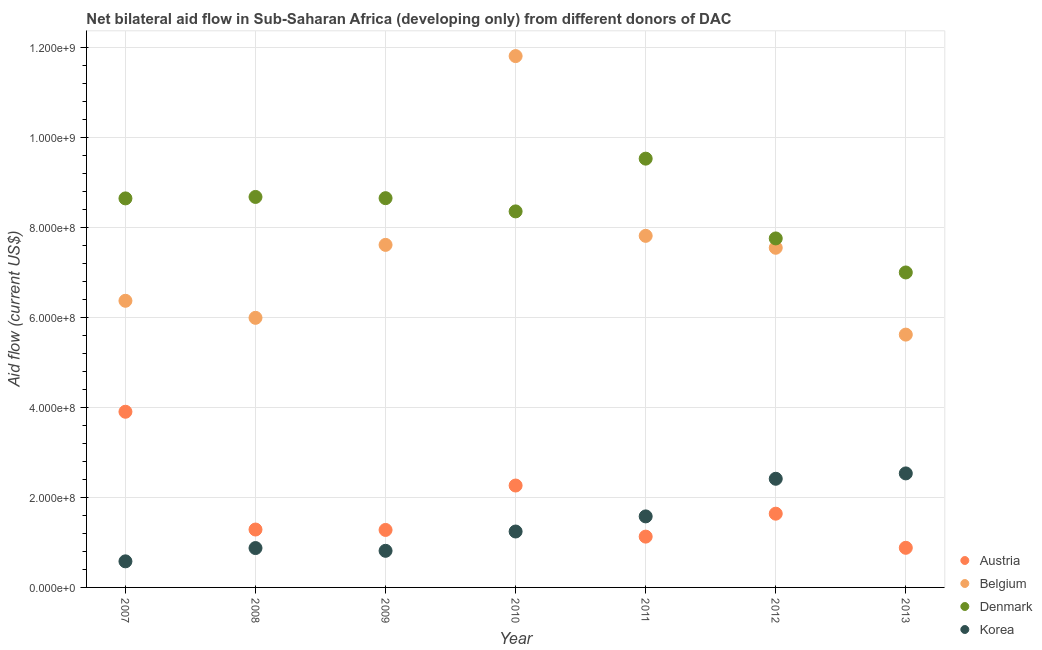Is the number of dotlines equal to the number of legend labels?
Your answer should be very brief. Yes. What is the amount of aid given by korea in 2010?
Provide a succinct answer. 1.24e+08. Across all years, what is the maximum amount of aid given by austria?
Give a very brief answer. 3.91e+08. Across all years, what is the minimum amount of aid given by belgium?
Your response must be concise. 5.62e+08. In which year was the amount of aid given by austria maximum?
Offer a terse response. 2007. What is the total amount of aid given by belgium in the graph?
Offer a terse response. 5.28e+09. What is the difference between the amount of aid given by austria in 2007 and that in 2010?
Your answer should be very brief. 1.64e+08. What is the difference between the amount of aid given by korea in 2011 and the amount of aid given by austria in 2010?
Your answer should be very brief. -6.86e+07. What is the average amount of aid given by korea per year?
Your response must be concise. 1.44e+08. In the year 2010, what is the difference between the amount of aid given by korea and amount of aid given by denmark?
Your answer should be very brief. -7.12e+08. What is the ratio of the amount of aid given by austria in 2011 to that in 2013?
Your response must be concise. 1.28. Is the amount of aid given by korea in 2007 less than that in 2009?
Your answer should be very brief. Yes. Is the difference between the amount of aid given by belgium in 2009 and 2011 greater than the difference between the amount of aid given by denmark in 2009 and 2011?
Ensure brevity in your answer.  Yes. What is the difference between the highest and the second highest amount of aid given by korea?
Offer a very short reply. 1.19e+07. What is the difference between the highest and the lowest amount of aid given by belgium?
Keep it short and to the point. 6.19e+08. Is the sum of the amount of aid given by belgium in 2008 and 2009 greater than the maximum amount of aid given by denmark across all years?
Give a very brief answer. Yes. Is the amount of aid given by denmark strictly greater than the amount of aid given by korea over the years?
Offer a terse response. Yes. How many dotlines are there?
Ensure brevity in your answer.  4. Where does the legend appear in the graph?
Ensure brevity in your answer.  Bottom right. How many legend labels are there?
Give a very brief answer. 4. What is the title of the graph?
Offer a very short reply. Net bilateral aid flow in Sub-Saharan Africa (developing only) from different donors of DAC. What is the Aid flow (current US$) in Austria in 2007?
Give a very brief answer. 3.91e+08. What is the Aid flow (current US$) in Belgium in 2007?
Your response must be concise. 6.38e+08. What is the Aid flow (current US$) of Denmark in 2007?
Give a very brief answer. 8.65e+08. What is the Aid flow (current US$) in Korea in 2007?
Keep it short and to the point. 5.80e+07. What is the Aid flow (current US$) of Austria in 2008?
Your answer should be very brief. 1.29e+08. What is the Aid flow (current US$) of Belgium in 2008?
Your answer should be very brief. 6.00e+08. What is the Aid flow (current US$) of Denmark in 2008?
Provide a succinct answer. 8.68e+08. What is the Aid flow (current US$) of Korea in 2008?
Your response must be concise. 8.76e+07. What is the Aid flow (current US$) of Austria in 2009?
Provide a succinct answer. 1.28e+08. What is the Aid flow (current US$) of Belgium in 2009?
Your answer should be compact. 7.62e+08. What is the Aid flow (current US$) of Denmark in 2009?
Provide a succinct answer. 8.66e+08. What is the Aid flow (current US$) of Korea in 2009?
Make the answer very short. 8.14e+07. What is the Aid flow (current US$) in Austria in 2010?
Provide a succinct answer. 2.27e+08. What is the Aid flow (current US$) in Belgium in 2010?
Your response must be concise. 1.18e+09. What is the Aid flow (current US$) in Denmark in 2010?
Your answer should be very brief. 8.36e+08. What is the Aid flow (current US$) of Korea in 2010?
Provide a succinct answer. 1.24e+08. What is the Aid flow (current US$) in Austria in 2011?
Provide a short and direct response. 1.13e+08. What is the Aid flow (current US$) of Belgium in 2011?
Offer a terse response. 7.82e+08. What is the Aid flow (current US$) in Denmark in 2011?
Your answer should be very brief. 9.54e+08. What is the Aid flow (current US$) of Korea in 2011?
Keep it short and to the point. 1.58e+08. What is the Aid flow (current US$) of Austria in 2012?
Your answer should be compact. 1.64e+08. What is the Aid flow (current US$) of Belgium in 2012?
Provide a succinct answer. 7.55e+08. What is the Aid flow (current US$) of Denmark in 2012?
Make the answer very short. 7.76e+08. What is the Aid flow (current US$) in Korea in 2012?
Provide a succinct answer. 2.42e+08. What is the Aid flow (current US$) in Austria in 2013?
Your response must be concise. 8.81e+07. What is the Aid flow (current US$) of Belgium in 2013?
Your response must be concise. 5.62e+08. What is the Aid flow (current US$) in Denmark in 2013?
Provide a short and direct response. 7.01e+08. What is the Aid flow (current US$) of Korea in 2013?
Give a very brief answer. 2.54e+08. Across all years, what is the maximum Aid flow (current US$) in Austria?
Your response must be concise. 3.91e+08. Across all years, what is the maximum Aid flow (current US$) of Belgium?
Provide a short and direct response. 1.18e+09. Across all years, what is the maximum Aid flow (current US$) of Denmark?
Provide a succinct answer. 9.54e+08. Across all years, what is the maximum Aid flow (current US$) of Korea?
Your answer should be compact. 2.54e+08. Across all years, what is the minimum Aid flow (current US$) in Austria?
Your answer should be compact. 8.81e+07. Across all years, what is the minimum Aid flow (current US$) of Belgium?
Provide a short and direct response. 5.62e+08. Across all years, what is the minimum Aid flow (current US$) of Denmark?
Keep it short and to the point. 7.01e+08. Across all years, what is the minimum Aid flow (current US$) in Korea?
Ensure brevity in your answer.  5.80e+07. What is the total Aid flow (current US$) in Austria in the graph?
Keep it short and to the point. 1.24e+09. What is the total Aid flow (current US$) of Belgium in the graph?
Your answer should be compact. 5.28e+09. What is the total Aid flow (current US$) of Denmark in the graph?
Ensure brevity in your answer.  5.87e+09. What is the total Aid flow (current US$) of Korea in the graph?
Provide a succinct answer. 1.00e+09. What is the difference between the Aid flow (current US$) of Austria in 2007 and that in 2008?
Ensure brevity in your answer.  2.62e+08. What is the difference between the Aid flow (current US$) of Belgium in 2007 and that in 2008?
Keep it short and to the point. 3.79e+07. What is the difference between the Aid flow (current US$) in Denmark in 2007 and that in 2008?
Offer a very short reply. -3.24e+06. What is the difference between the Aid flow (current US$) in Korea in 2007 and that in 2008?
Make the answer very short. -2.95e+07. What is the difference between the Aid flow (current US$) in Austria in 2007 and that in 2009?
Ensure brevity in your answer.  2.63e+08. What is the difference between the Aid flow (current US$) of Belgium in 2007 and that in 2009?
Provide a short and direct response. -1.24e+08. What is the difference between the Aid flow (current US$) in Denmark in 2007 and that in 2009?
Your answer should be very brief. -5.00e+05. What is the difference between the Aid flow (current US$) of Korea in 2007 and that in 2009?
Provide a short and direct response. -2.34e+07. What is the difference between the Aid flow (current US$) in Austria in 2007 and that in 2010?
Provide a succinct answer. 1.64e+08. What is the difference between the Aid flow (current US$) of Belgium in 2007 and that in 2010?
Provide a succinct answer. -5.44e+08. What is the difference between the Aid flow (current US$) in Denmark in 2007 and that in 2010?
Keep it short and to the point. 2.89e+07. What is the difference between the Aid flow (current US$) of Korea in 2007 and that in 2010?
Keep it short and to the point. -6.64e+07. What is the difference between the Aid flow (current US$) of Austria in 2007 and that in 2011?
Provide a succinct answer. 2.78e+08. What is the difference between the Aid flow (current US$) in Belgium in 2007 and that in 2011?
Provide a succinct answer. -1.44e+08. What is the difference between the Aid flow (current US$) of Denmark in 2007 and that in 2011?
Your answer should be compact. -8.84e+07. What is the difference between the Aid flow (current US$) of Korea in 2007 and that in 2011?
Provide a short and direct response. -1.00e+08. What is the difference between the Aid flow (current US$) in Austria in 2007 and that in 2012?
Your answer should be very brief. 2.27e+08. What is the difference between the Aid flow (current US$) in Belgium in 2007 and that in 2012?
Make the answer very short. -1.18e+08. What is the difference between the Aid flow (current US$) of Denmark in 2007 and that in 2012?
Give a very brief answer. 8.90e+07. What is the difference between the Aid flow (current US$) in Korea in 2007 and that in 2012?
Your response must be concise. -1.84e+08. What is the difference between the Aid flow (current US$) of Austria in 2007 and that in 2013?
Make the answer very short. 3.03e+08. What is the difference between the Aid flow (current US$) in Belgium in 2007 and that in 2013?
Ensure brevity in your answer.  7.52e+07. What is the difference between the Aid flow (current US$) in Denmark in 2007 and that in 2013?
Give a very brief answer. 1.65e+08. What is the difference between the Aid flow (current US$) of Korea in 2007 and that in 2013?
Ensure brevity in your answer.  -1.96e+08. What is the difference between the Aid flow (current US$) of Austria in 2008 and that in 2009?
Give a very brief answer. 9.10e+05. What is the difference between the Aid flow (current US$) in Belgium in 2008 and that in 2009?
Offer a very short reply. -1.62e+08. What is the difference between the Aid flow (current US$) of Denmark in 2008 and that in 2009?
Offer a terse response. 2.74e+06. What is the difference between the Aid flow (current US$) of Korea in 2008 and that in 2009?
Ensure brevity in your answer.  6.12e+06. What is the difference between the Aid flow (current US$) of Austria in 2008 and that in 2010?
Give a very brief answer. -9.78e+07. What is the difference between the Aid flow (current US$) of Belgium in 2008 and that in 2010?
Keep it short and to the point. -5.82e+08. What is the difference between the Aid flow (current US$) in Denmark in 2008 and that in 2010?
Your answer should be very brief. 3.21e+07. What is the difference between the Aid flow (current US$) in Korea in 2008 and that in 2010?
Ensure brevity in your answer.  -3.68e+07. What is the difference between the Aid flow (current US$) of Austria in 2008 and that in 2011?
Provide a short and direct response. 1.58e+07. What is the difference between the Aid flow (current US$) of Belgium in 2008 and that in 2011?
Provide a succinct answer. -1.82e+08. What is the difference between the Aid flow (current US$) in Denmark in 2008 and that in 2011?
Ensure brevity in your answer.  -8.52e+07. What is the difference between the Aid flow (current US$) of Korea in 2008 and that in 2011?
Offer a terse response. -7.04e+07. What is the difference between the Aid flow (current US$) of Austria in 2008 and that in 2012?
Make the answer very short. -3.52e+07. What is the difference between the Aid flow (current US$) in Belgium in 2008 and that in 2012?
Your answer should be compact. -1.56e+08. What is the difference between the Aid flow (current US$) of Denmark in 2008 and that in 2012?
Your answer should be compact. 9.23e+07. What is the difference between the Aid flow (current US$) in Korea in 2008 and that in 2012?
Offer a terse response. -1.54e+08. What is the difference between the Aid flow (current US$) in Austria in 2008 and that in 2013?
Make the answer very short. 4.07e+07. What is the difference between the Aid flow (current US$) of Belgium in 2008 and that in 2013?
Your answer should be compact. 3.73e+07. What is the difference between the Aid flow (current US$) of Denmark in 2008 and that in 2013?
Provide a succinct answer. 1.68e+08. What is the difference between the Aid flow (current US$) of Korea in 2008 and that in 2013?
Keep it short and to the point. -1.66e+08. What is the difference between the Aid flow (current US$) in Austria in 2009 and that in 2010?
Make the answer very short. -9.88e+07. What is the difference between the Aid flow (current US$) in Belgium in 2009 and that in 2010?
Offer a very short reply. -4.20e+08. What is the difference between the Aid flow (current US$) of Denmark in 2009 and that in 2010?
Make the answer very short. 2.94e+07. What is the difference between the Aid flow (current US$) in Korea in 2009 and that in 2010?
Offer a terse response. -4.29e+07. What is the difference between the Aid flow (current US$) of Austria in 2009 and that in 2011?
Make the answer very short. 1.49e+07. What is the difference between the Aid flow (current US$) in Belgium in 2009 and that in 2011?
Your answer should be compact. -2.01e+07. What is the difference between the Aid flow (current US$) in Denmark in 2009 and that in 2011?
Your answer should be compact. -8.79e+07. What is the difference between the Aid flow (current US$) of Korea in 2009 and that in 2011?
Keep it short and to the point. -7.66e+07. What is the difference between the Aid flow (current US$) of Austria in 2009 and that in 2012?
Make the answer very short. -3.61e+07. What is the difference between the Aid flow (current US$) of Belgium in 2009 and that in 2012?
Make the answer very short. 6.45e+06. What is the difference between the Aid flow (current US$) in Denmark in 2009 and that in 2012?
Your response must be concise. 8.95e+07. What is the difference between the Aid flow (current US$) of Korea in 2009 and that in 2012?
Your answer should be compact. -1.60e+08. What is the difference between the Aid flow (current US$) of Austria in 2009 and that in 2013?
Ensure brevity in your answer.  3.98e+07. What is the difference between the Aid flow (current US$) of Belgium in 2009 and that in 2013?
Make the answer very short. 2.00e+08. What is the difference between the Aid flow (current US$) of Denmark in 2009 and that in 2013?
Offer a very short reply. 1.65e+08. What is the difference between the Aid flow (current US$) of Korea in 2009 and that in 2013?
Your response must be concise. -1.72e+08. What is the difference between the Aid flow (current US$) in Austria in 2010 and that in 2011?
Your answer should be very brief. 1.14e+08. What is the difference between the Aid flow (current US$) of Belgium in 2010 and that in 2011?
Provide a short and direct response. 4.00e+08. What is the difference between the Aid flow (current US$) in Denmark in 2010 and that in 2011?
Provide a succinct answer. -1.17e+08. What is the difference between the Aid flow (current US$) in Korea in 2010 and that in 2011?
Provide a short and direct response. -3.36e+07. What is the difference between the Aid flow (current US$) of Austria in 2010 and that in 2012?
Your answer should be very brief. 6.26e+07. What is the difference between the Aid flow (current US$) in Belgium in 2010 and that in 2012?
Provide a short and direct response. 4.26e+08. What is the difference between the Aid flow (current US$) in Denmark in 2010 and that in 2012?
Keep it short and to the point. 6.01e+07. What is the difference between the Aid flow (current US$) in Korea in 2010 and that in 2012?
Provide a short and direct response. -1.17e+08. What is the difference between the Aid flow (current US$) of Austria in 2010 and that in 2013?
Ensure brevity in your answer.  1.39e+08. What is the difference between the Aid flow (current US$) of Belgium in 2010 and that in 2013?
Provide a succinct answer. 6.19e+08. What is the difference between the Aid flow (current US$) in Denmark in 2010 and that in 2013?
Provide a succinct answer. 1.36e+08. What is the difference between the Aid flow (current US$) of Korea in 2010 and that in 2013?
Offer a very short reply. -1.29e+08. What is the difference between the Aid flow (current US$) of Austria in 2011 and that in 2012?
Your answer should be compact. -5.10e+07. What is the difference between the Aid flow (current US$) in Belgium in 2011 and that in 2012?
Make the answer very short. 2.65e+07. What is the difference between the Aid flow (current US$) in Denmark in 2011 and that in 2012?
Offer a very short reply. 1.77e+08. What is the difference between the Aid flow (current US$) in Korea in 2011 and that in 2012?
Ensure brevity in your answer.  -8.37e+07. What is the difference between the Aid flow (current US$) of Austria in 2011 and that in 2013?
Keep it short and to the point. 2.49e+07. What is the difference between the Aid flow (current US$) in Belgium in 2011 and that in 2013?
Keep it short and to the point. 2.20e+08. What is the difference between the Aid flow (current US$) of Denmark in 2011 and that in 2013?
Keep it short and to the point. 2.53e+08. What is the difference between the Aid flow (current US$) of Korea in 2011 and that in 2013?
Offer a very short reply. -9.56e+07. What is the difference between the Aid flow (current US$) of Austria in 2012 and that in 2013?
Make the answer very short. 7.59e+07. What is the difference between the Aid flow (current US$) of Belgium in 2012 and that in 2013?
Your response must be concise. 1.93e+08. What is the difference between the Aid flow (current US$) in Denmark in 2012 and that in 2013?
Provide a succinct answer. 7.57e+07. What is the difference between the Aid flow (current US$) of Korea in 2012 and that in 2013?
Make the answer very short. -1.19e+07. What is the difference between the Aid flow (current US$) of Austria in 2007 and the Aid flow (current US$) of Belgium in 2008?
Keep it short and to the point. -2.09e+08. What is the difference between the Aid flow (current US$) of Austria in 2007 and the Aid flow (current US$) of Denmark in 2008?
Give a very brief answer. -4.78e+08. What is the difference between the Aid flow (current US$) of Austria in 2007 and the Aid flow (current US$) of Korea in 2008?
Your answer should be very brief. 3.03e+08. What is the difference between the Aid flow (current US$) of Belgium in 2007 and the Aid flow (current US$) of Denmark in 2008?
Your answer should be compact. -2.31e+08. What is the difference between the Aid flow (current US$) in Belgium in 2007 and the Aid flow (current US$) in Korea in 2008?
Your response must be concise. 5.50e+08. What is the difference between the Aid flow (current US$) in Denmark in 2007 and the Aid flow (current US$) in Korea in 2008?
Your answer should be compact. 7.78e+08. What is the difference between the Aid flow (current US$) of Austria in 2007 and the Aid flow (current US$) of Belgium in 2009?
Keep it short and to the point. -3.71e+08. What is the difference between the Aid flow (current US$) in Austria in 2007 and the Aid flow (current US$) in Denmark in 2009?
Your response must be concise. -4.75e+08. What is the difference between the Aid flow (current US$) in Austria in 2007 and the Aid flow (current US$) in Korea in 2009?
Your response must be concise. 3.09e+08. What is the difference between the Aid flow (current US$) in Belgium in 2007 and the Aid flow (current US$) in Denmark in 2009?
Your answer should be compact. -2.28e+08. What is the difference between the Aid flow (current US$) in Belgium in 2007 and the Aid flow (current US$) in Korea in 2009?
Make the answer very short. 5.56e+08. What is the difference between the Aid flow (current US$) in Denmark in 2007 and the Aid flow (current US$) in Korea in 2009?
Your response must be concise. 7.84e+08. What is the difference between the Aid flow (current US$) of Austria in 2007 and the Aid flow (current US$) of Belgium in 2010?
Give a very brief answer. -7.91e+08. What is the difference between the Aid flow (current US$) in Austria in 2007 and the Aid flow (current US$) in Denmark in 2010?
Provide a short and direct response. -4.46e+08. What is the difference between the Aid flow (current US$) of Austria in 2007 and the Aid flow (current US$) of Korea in 2010?
Offer a very short reply. 2.66e+08. What is the difference between the Aid flow (current US$) of Belgium in 2007 and the Aid flow (current US$) of Denmark in 2010?
Keep it short and to the point. -1.99e+08. What is the difference between the Aid flow (current US$) of Belgium in 2007 and the Aid flow (current US$) of Korea in 2010?
Your response must be concise. 5.13e+08. What is the difference between the Aid flow (current US$) in Denmark in 2007 and the Aid flow (current US$) in Korea in 2010?
Provide a short and direct response. 7.41e+08. What is the difference between the Aid flow (current US$) in Austria in 2007 and the Aid flow (current US$) in Belgium in 2011?
Offer a very short reply. -3.91e+08. What is the difference between the Aid flow (current US$) of Austria in 2007 and the Aid flow (current US$) of Denmark in 2011?
Provide a short and direct response. -5.63e+08. What is the difference between the Aid flow (current US$) of Austria in 2007 and the Aid flow (current US$) of Korea in 2011?
Your response must be concise. 2.33e+08. What is the difference between the Aid flow (current US$) in Belgium in 2007 and the Aid flow (current US$) in Denmark in 2011?
Make the answer very short. -3.16e+08. What is the difference between the Aid flow (current US$) in Belgium in 2007 and the Aid flow (current US$) in Korea in 2011?
Offer a terse response. 4.80e+08. What is the difference between the Aid flow (current US$) in Denmark in 2007 and the Aid flow (current US$) in Korea in 2011?
Make the answer very short. 7.07e+08. What is the difference between the Aid flow (current US$) in Austria in 2007 and the Aid flow (current US$) in Belgium in 2012?
Keep it short and to the point. -3.65e+08. What is the difference between the Aid flow (current US$) of Austria in 2007 and the Aid flow (current US$) of Denmark in 2012?
Offer a very short reply. -3.85e+08. What is the difference between the Aid flow (current US$) in Austria in 2007 and the Aid flow (current US$) in Korea in 2012?
Provide a short and direct response. 1.49e+08. What is the difference between the Aid flow (current US$) in Belgium in 2007 and the Aid flow (current US$) in Denmark in 2012?
Your answer should be very brief. -1.39e+08. What is the difference between the Aid flow (current US$) of Belgium in 2007 and the Aid flow (current US$) of Korea in 2012?
Provide a succinct answer. 3.96e+08. What is the difference between the Aid flow (current US$) of Denmark in 2007 and the Aid flow (current US$) of Korea in 2012?
Make the answer very short. 6.24e+08. What is the difference between the Aid flow (current US$) of Austria in 2007 and the Aid flow (current US$) of Belgium in 2013?
Ensure brevity in your answer.  -1.72e+08. What is the difference between the Aid flow (current US$) of Austria in 2007 and the Aid flow (current US$) of Denmark in 2013?
Your answer should be compact. -3.10e+08. What is the difference between the Aid flow (current US$) of Austria in 2007 and the Aid flow (current US$) of Korea in 2013?
Ensure brevity in your answer.  1.37e+08. What is the difference between the Aid flow (current US$) in Belgium in 2007 and the Aid flow (current US$) in Denmark in 2013?
Keep it short and to the point. -6.30e+07. What is the difference between the Aid flow (current US$) of Belgium in 2007 and the Aid flow (current US$) of Korea in 2013?
Your answer should be very brief. 3.84e+08. What is the difference between the Aid flow (current US$) of Denmark in 2007 and the Aid flow (current US$) of Korea in 2013?
Your answer should be compact. 6.12e+08. What is the difference between the Aid flow (current US$) in Austria in 2008 and the Aid flow (current US$) in Belgium in 2009?
Keep it short and to the point. -6.33e+08. What is the difference between the Aid flow (current US$) of Austria in 2008 and the Aid flow (current US$) of Denmark in 2009?
Provide a succinct answer. -7.37e+08. What is the difference between the Aid flow (current US$) in Austria in 2008 and the Aid flow (current US$) in Korea in 2009?
Your answer should be very brief. 4.74e+07. What is the difference between the Aid flow (current US$) in Belgium in 2008 and the Aid flow (current US$) in Denmark in 2009?
Offer a very short reply. -2.66e+08. What is the difference between the Aid flow (current US$) in Belgium in 2008 and the Aid flow (current US$) in Korea in 2009?
Keep it short and to the point. 5.18e+08. What is the difference between the Aid flow (current US$) in Denmark in 2008 and the Aid flow (current US$) in Korea in 2009?
Your answer should be compact. 7.87e+08. What is the difference between the Aid flow (current US$) in Austria in 2008 and the Aid flow (current US$) in Belgium in 2010?
Ensure brevity in your answer.  -1.05e+09. What is the difference between the Aid flow (current US$) in Austria in 2008 and the Aid flow (current US$) in Denmark in 2010?
Give a very brief answer. -7.08e+08. What is the difference between the Aid flow (current US$) of Austria in 2008 and the Aid flow (current US$) of Korea in 2010?
Provide a succinct answer. 4.41e+06. What is the difference between the Aid flow (current US$) in Belgium in 2008 and the Aid flow (current US$) in Denmark in 2010?
Your answer should be compact. -2.37e+08. What is the difference between the Aid flow (current US$) of Belgium in 2008 and the Aid flow (current US$) of Korea in 2010?
Provide a succinct answer. 4.75e+08. What is the difference between the Aid flow (current US$) in Denmark in 2008 and the Aid flow (current US$) in Korea in 2010?
Your answer should be very brief. 7.44e+08. What is the difference between the Aid flow (current US$) of Austria in 2008 and the Aid flow (current US$) of Belgium in 2011?
Your response must be concise. -6.53e+08. What is the difference between the Aid flow (current US$) of Austria in 2008 and the Aid flow (current US$) of Denmark in 2011?
Give a very brief answer. -8.25e+08. What is the difference between the Aid flow (current US$) in Austria in 2008 and the Aid flow (current US$) in Korea in 2011?
Offer a very short reply. -2.92e+07. What is the difference between the Aid flow (current US$) in Belgium in 2008 and the Aid flow (current US$) in Denmark in 2011?
Make the answer very short. -3.54e+08. What is the difference between the Aid flow (current US$) in Belgium in 2008 and the Aid flow (current US$) in Korea in 2011?
Make the answer very short. 4.42e+08. What is the difference between the Aid flow (current US$) of Denmark in 2008 and the Aid flow (current US$) of Korea in 2011?
Offer a very short reply. 7.10e+08. What is the difference between the Aid flow (current US$) in Austria in 2008 and the Aid flow (current US$) in Belgium in 2012?
Your answer should be very brief. -6.27e+08. What is the difference between the Aid flow (current US$) in Austria in 2008 and the Aid flow (current US$) in Denmark in 2012?
Your response must be concise. -6.47e+08. What is the difference between the Aid flow (current US$) of Austria in 2008 and the Aid flow (current US$) of Korea in 2012?
Keep it short and to the point. -1.13e+08. What is the difference between the Aid flow (current US$) in Belgium in 2008 and the Aid flow (current US$) in Denmark in 2012?
Provide a short and direct response. -1.77e+08. What is the difference between the Aid flow (current US$) in Belgium in 2008 and the Aid flow (current US$) in Korea in 2012?
Provide a short and direct response. 3.58e+08. What is the difference between the Aid flow (current US$) in Denmark in 2008 and the Aid flow (current US$) in Korea in 2012?
Provide a succinct answer. 6.27e+08. What is the difference between the Aid flow (current US$) of Austria in 2008 and the Aid flow (current US$) of Belgium in 2013?
Give a very brief answer. -4.34e+08. What is the difference between the Aid flow (current US$) of Austria in 2008 and the Aid flow (current US$) of Denmark in 2013?
Offer a very short reply. -5.72e+08. What is the difference between the Aid flow (current US$) of Austria in 2008 and the Aid flow (current US$) of Korea in 2013?
Keep it short and to the point. -1.25e+08. What is the difference between the Aid flow (current US$) of Belgium in 2008 and the Aid flow (current US$) of Denmark in 2013?
Provide a short and direct response. -1.01e+08. What is the difference between the Aid flow (current US$) in Belgium in 2008 and the Aid flow (current US$) in Korea in 2013?
Your answer should be very brief. 3.46e+08. What is the difference between the Aid flow (current US$) in Denmark in 2008 and the Aid flow (current US$) in Korea in 2013?
Ensure brevity in your answer.  6.15e+08. What is the difference between the Aid flow (current US$) in Austria in 2009 and the Aid flow (current US$) in Belgium in 2010?
Ensure brevity in your answer.  -1.05e+09. What is the difference between the Aid flow (current US$) in Austria in 2009 and the Aid flow (current US$) in Denmark in 2010?
Ensure brevity in your answer.  -7.08e+08. What is the difference between the Aid flow (current US$) of Austria in 2009 and the Aid flow (current US$) of Korea in 2010?
Your answer should be very brief. 3.50e+06. What is the difference between the Aid flow (current US$) in Belgium in 2009 and the Aid flow (current US$) in Denmark in 2010?
Provide a succinct answer. -7.45e+07. What is the difference between the Aid flow (current US$) of Belgium in 2009 and the Aid flow (current US$) of Korea in 2010?
Keep it short and to the point. 6.37e+08. What is the difference between the Aid flow (current US$) of Denmark in 2009 and the Aid flow (current US$) of Korea in 2010?
Ensure brevity in your answer.  7.41e+08. What is the difference between the Aid flow (current US$) in Austria in 2009 and the Aid flow (current US$) in Belgium in 2011?
Your answer should be very brief. -6.54e+08. What is the difference between the Aid flow (current US$) of Austria in 2009 and the Aid flow (current US$) of Denmark in 2011?
Your answer should be very brief. -8.26e+08. What is the difference between the Aid flow (current US$) in Austria in 2009 and the Aid flow (current US$) in Korea in 2011?
Keep it short and to the point. -3.01e+07. What is the difference between the Aid flow (current US$) of Belgium in 2009 and the Aid flow (current US$) of Denmark in 2011?
Keep it short and to the point. -1.92e+08. What is the difference between the Aid flow (current US$) in Belgium in 2009 and the Aid flow (current US$) in Korea in 2011?
Make the answer very short. 6.04e+08. What is the difference between the Aid flow (current US$) of Denmark in 2009 and the Aid flow (current US$) of Korea in 2011?
Offer a very short reply. 7.08e+08. What is the difference between the Aid flow (current US$) in Austria in 2009 and the Aid flow (current US$) in Belgium in 2012?
Make the answer very short. -6.28e+08. What is the difference between the Aid flow (current US$) in Austria in 2009 and the Aid flow (current US$) in Denmark in 2012?
Give a very brief answer. -6.48e+08. What is the difference between the Aid flow (current US$) of Austria in 2009 and the Aid flow (current US$) of Korea in 2012?
Ensure brevity in your answer.  -1.14e+08. What is the difference between the Aid flow (current US$) of Belgium in 2009 and the Aid flow (current US$) of Denmark in 2012?
Provide a short and direct response. -1.43e+07. What is the difference between the Aid flow (current US$) of Belgium in 2009 and the Aid flow (current US$) of Korea in 2012?
Your response must be concise. 5.20e+08. What is the difference between the Aid flow (current US$) of Denmark in 2009 and the Aid flow (current US$) of Korea in 2012?
Make the answer very short. 6.24e+08. What is the difference between the Aid flow (current US$) in Austria in 2009 and the Aid flow (current US$) in Belgium in 2013?
Offer a terse response. -4.34e+08. What is the difference between the Aid flow (current US$) of Austria in 2009 and the Aid flow (current US$) of Denmark in 2013?
Your answer should be very brief. -5.73e+08. What is the difference between the Aid flow (current US$) in Austria in 2009 and the Aid flow (current US$) in Korea in 2013?
Your answer should be very brief. -1.26e+08. What is the difference between the Aid flow (current US$) in Belgium in 2009 and the Aid flow (current US$) in Denmark in 2013?
Offer a very short reply. 6.14e+07. What is the difference between the Aid flow (current US$) of Belgium in 2009 and the Aid flow (current US$) of Korea in 2013?
Give a very brief answer. 5.08e+08. What is the difference between the Aid flow (current US$) of Denmark in 2009 and the Aid flow (current US$) of Korea in 2013?
Offer a terse response. 6.12e+08. What is the difference between the Aid flow (current US$) in Austria in 2010 and the Aid flow (current US$) in Belgium in 2011?
Your answer should be compact. -5.55e+08. What is the difference between the Aid flow (current US$) of Austria in 2010 and the Aid flow (current US$) of Denmark in 2011?
Ensure brevity in your answer.  -7.27e+08. What is the difference between the Aid flow (current US$) of Austria in 2010 and the Aid flow (current US$) of Korea in 2011?
Your answer should be compact. 6.86e+07. What is the difference between the Aid flow (current US$) of Belgium in 2010 and the Aid flow (current US$) of Denmark in 2011?
Provide a short and direct response. 2.28e+08. What is the difference between the Aid flow (current US$) of Belgium in 2010 and the Aid flow (current US$) of Korea in 2011?
Keep it short and to the point. 1.02e+09. What is the difference between the Aid flow (current US$) in Denmark in 2010 and the Aid flow (current US$) in Korea in 2011?
Ensure brevity in your answer.  6.78e+08. What is the difference between the Aid flow (current US$) in Austria in 2010 and the Aid flow (current US$) in Belgium in 2012?
Keep it short and to the point. -5.29e+08. What is the difference between the Aid flow (current US$) in Austria in 2010 and the Aid flow (current US$) in Denmark in 2012?
Give a very brief answer. -5.50e+08. What is the difference between the Aid flow (current US$) of Austria in 2010 and the Aid flow (current US$) of Korea in 2012?
Offer a very short reply. -1.50e+07. What is the difference between the Aid flow (current US$) of Belgium in 2010 and the Aid flow (current US$) of Denmark in 2012?
Give a very brief answer. 4.06e+08. What is the difference between the Aid flow (current US$) in Belgium in 2010 and the Aid flow (current US$) in Korea in 2012?
Give a very brief answer. 9.40e+08. What is the difference between the Aid flow (current US$) in Denmark in 2010 and the Aid flow (current US$) in Korea in 2012?
Make the answer very short. 5.95e+08. What is the difference between the Aid flow (current US$) of Austria in 2010 and the Aid flow (current US$) of Belgium in 2013?
Provide a short and direct response. -3.36e+08. What is the difference between the Aid flow (current US$) of Austria in 2010 and the Aid flow (current US$) of Denmark in 2013?
Offer a very short reply. -4.74e+08. What is the difference between the Aid flow (current US$) in Austria in 2010 and the Aid flow (current US$) in Korea in 2013?
Make the answer very short. -2.70e+07. What is the difference between the Aid flow (current US$) of Belgium in 2010 and the Aid flow (current US$) of Denmark in 2013?
Keep it short and to the point. 4.81e+08. What is the difference between the Aid flow (current US$) in Belgium in 2010 and the Aid flow (current US$) in Korea in 2013?
Ensure brevity in your answer.  9.28e+08. What is the difference between the Aid flow (current US$) in Denmark in 2010 and the Aid flow (current US$) in Korea in 2013?
Your response must be concise. 5.83e+08. What is the difference between the Aid flow (current US$) in Austria in 2011 and the Aid flow (current US$) in Belgium in 2012?
Provide a short and direct response. -6.42e+08. What is the difference between the Aid flow (current US$) in Austria in 2011 and the Aid flow (current US$) in Denmark in 2012?
Give a very brief answer. -6.63e+08. What is the difference between the Aid flow (current US$) in Austria in 2011 and the Aid flow (current US$) in Korea in 2012?
Keep it short and to the point. -1.29e+08. What is the difference between the Aid flow (current US$) of Belgium in 2011 and the Aid flow (current US$) of Denmark in 2012?
Give a very brief answer. 5.74e+06. What is the difference between the Aid flow (current US$) in Belgium in 2011 and the Aid flow (current US$) in Korea in 2012?
Your answer should be compact. 5.40e+08. What is the difference between the Aid flow (current US$) in Denmark in 2011 and the Aid flow (current US$) in Korea in 2012?
Your answer should be compact. 7.12e+08. What is the difference between the Aid flow (current US$) of Austria in 2011 and the Aid flow (current US$) of Belgium in 2013?
Your answer should be very brief. -4.49e+08. What is the difference between the Aid flow (current US$) of Austria in 2011 and the Aid flow (current US$) of Denmark in 2013?
Provide a short and direct response. -5.88e+08. What is the difference between the Aid flow (current US$) in Austria in 2011 and the Aid flow (current US$) in Korea in 2013?
Keep it short and to the point. -1.41e+08. What is the difference between the Aid flow (current US$) of Belgium in 2011 and the Aid flow (current US$) of Denmark in 2013?
Provide a short and direct response. 8.14e+07. What is the difference between the Aid flow (current US$) of Belgium in 2011 and the Aid flow (current US$) of Korea in 2013?
Your answer should be very brief. 5.28e+08. What is the difference between the Aid flow (current US$) in Denmark in 2011 and the Aid flow (current US$) in Korea in 2013?
Keep it short and to the point. 7.00e+08. What is the difference between the Aid flow (current US$) of Austria in 2012 and the Aid flow (current US$) of Belgium in 2013?
Your answer should be very brief. -3.98e+08. What is the difference between the Aid flow (current US$) of Austria in 2012 and the Aid flow (current US$) of Denmark in 2013?
Provide a short and direct response. -5.36e+08. What is the difference between the Aid flow (current US$) of Austria in 2012 and the Aid flow (current US$) of Korea in 2013?
Keep it short and to the point. -8.96e+07. What is the difference between the Aid flow (current US$) of Belgium in 2012 and the Aid flow (current US$) of Denmark in 2013?
Provide a short and direct response. 5.49e+07. What is the difference between the Aid flow (current US$) of Belgium in 2012 and the Aid flow (current US$) of Korea in 2013?
Offer a very short reply. 5.02e+08. What is the difference between the Aid flow (current US$) of Denmark in 2012 and the Aid flow (current US$) of Korea in 2013?
Your response must be concise. 5.23e+08. What is the average Aid flow (current US$) in Austria per year?
Provide a succinct answer. 1.77e+08. What is the average Aid flow (current US$) in Belgium per year?
Give a very brief answer. 7.54e+08. What is the average Aid flow (current US$) in Denmark per year?
Provide a succinct answer. 8.38e+08. What is the average Aid flow (current US$) of Korea per year?
Your answer should be compact. 1.44e+08. In the year 2007, what is the difference between the Aid flow (current US$) of Austria and Aid flow (current US$) of Belgium?
Your answer should be very brief. -2.47e+08. In the year 2007, what is the difference between the Aid flow (current US$) of Austria and Aid flow (current US$) of Denmark?
Your answer should be very brief. -4.75e+08. In the year 2007, what is the difference between the Aid flow (current US$) in Austria and Aid flow (current US$) in Korea?
Keep it short and to the point. 3.33e+08. In the year 2007, what is the difference between the Aid flow (current US$) in Belgium and Aid flow (current US$) in Denmark?
Ensure brevity in your answer.  -2.28e+08. In the year 2007, what is the difference between the Aid flow (current US$) in Belgium and Aid flow (current US$) in Korea?
Provide a succinct answer. 5.79e+08. In the year 2007, what is the difference between the Aid flow (current US$) in Denmark and Aid flow (current US$) in Korea?
Ensure brevity in your answer.  8.07e+08. In the year 2008, what is the difference between the Aid flow (current US$) of Austria and Aid flow (current US$) of Belgium?
Offer a terse response. -4.71e+08. In the year 2008, what is the difference between the Aid flow (current US$) of Austria and Aid flow (current US$) of Denmark?
Provide a short and direct response. -7.40e+08. In the year 2008, what is the difference between the Aid flow (current US$) in Austria and Aid flow (current US$) in Korea?
Your response must be concise. 4.12e+07. In the year 2008, what is the difference between the Aid flow (current US$) in Belgium and Aid flow (current US$) in Denmark?
Offer a terse response. -2.69e+08. In the year 2008, what is the difference between the Aid flow (current US$) in Belgium and Aid flow (current US$) in Korea?
Offer a very short reply. 5.12e+08. In the year 2008, what is the difference between the Aid flow (current US$) of Denmark and Aid flow (current US$) of Korea?
Your answer should be compact. 7.81e+08. In the year 2009, what is the difference between the Aid flow (current US$) in Austria and Aid flow (current US$) in Belgium?
Ensure brevity in your answer.  -6.34e+08. In the year 2009, what is the difference between the Aid flow (current US$) of Austria and Aid flow (current US$) of Denmark?
Your answer should be very brief. -7.38e+08. In the year 2009, what is the difference between the Aid flow (current US$) in Austria and Aid flow (current US$) in Korea?
Make the answer very short. 4.64e+07. In the year 2009, what is the difference between the Aid flow (current US$) in Belgium and Aid flow (current US$) in Denmark?
Offer a terse response. -1.04e+08. In the year 2009, what is the difference between the Aid flow (current US$) in Belgium and Aid flow (current US$) in Korea?
Provide a short and direct response. 6.80e+08. In the year 2009, what is the difference between the Aid flow (current US$) of Denmark and Aid flow (current US$) of Korea?
Offer a very short reply. 7.84e+08. In the year 2010, what is the difference between the Aid flow (current US$) of Austria and Aid flow (current US$) of Belgium?
Keep it short and to the point. -9.55e+08. In the year 2010, what is the difference between the Aid flow (current US$) in Austria and Aid flow (current US$) in Denmark?
Offer a terse response. -6.10e+08. In the year 2010, what is the difference between the Aid flow (current US$) of Austria and Aid flow (current US$) of Korea?
Make the answer very short. 1.02e+08. In the year 2010, what is the difference between the Aid flow (current US$) in Belgium and Aid flow (current US$) in Denmark?
Your response must be concise. 3.45e+08. In the year 2010, what is the difference between the Aid flow (current US$) of Belgium and Aid flow (current US$) of Korea?
Offer a terse response. 1.06e+09. In the year 2010, what is the difference between the Aid flow (current US$) in Denmark and Aid flow (current US$) in Korea?
Ensure brevity in your answer.  7.12e+08. In the year 2011, what is the difference between the Aid flow (current US$) in Austria and Aid flow (current US$) in Belgium?
Your answer should be very brief. -6.69e+08. In the year 2011, what is the difference between the Aid flow (current US$) of Austria and Aid flow (current US$) of Denmark?
Your answer should be very brief. -8.41e+08. In the year 2011, what is the difference between the Aid flow (current US$) of Austria and Aid flow (current US$) of Korea?
Offer a terse response. -4.50e+07. In the year 2011, what is the difference between the Aid flow (current US$) in Belgium and Aid flow (current US$) in Denmark?
Your response must be concise. -1.72e+08. In the year 2011, what is the difference between the Aid flow (current US$) in Belgium and Aid flow (current US$) in Korea?
Give a very brief answer. 6.24e+08. In the year 2011, what is the difference between the Aid flow (current US$) in Denmark and Aid flow (current US$) in Korea?
Provide a short and direct response. 7.96e+08. In the year 2012, what is the difference between the Aid flow (current US$) in Austria and Aid flow (current US$) in Belgium?
Offer a very short reply. -5.91e+08. In the year 2012, what is the difference between the Aid flow (current US$) of Austria and Aid flow (current US$) of Denmark?
Provide a short and direct response. -6.12e+08. In the year 2012, what is the difference between the Aid flow (current US$) of Austria and Aid flow (current US$) of Korea?
Your response must be concise. -7.77e+07. In the year 2012, what is the difference between the Aid flow (current US$) in Belgium and Aid flow (current US$) in Denmark?
Your answer should be very brief. -2.08e+07. In the year 2012, what is the difference between the Aid flow (current US$) in Belgium and Aid flow (current US$) in Korea?
Your answer should be very brief. 5.14e+08. In the year 2012, what is the difference between the Aid flow (current US$) of Denmark and Aid flow (current US$) of Korea?
Provide a short and direct response. 5.35e+08. In the year 2013, what is the difference between the Aid flow (current US$) of Austria and Aid flow (current US$) of Belgium?
Give a very brief answer. -4.74e+08. In the year 2013, what is the difference between the Aid flow (current US$) in Austria and Aid flow (current US$) in Denmark?
Provide a short and direct response. -6.12e+08. In the year 2013, what is the difference between the Aid flow (current US$) in Austria and Aid flow (current US$) in Korea?
Provide a short and direct response. -1.65e+08. In the year 2013, what is the difference between the Aid flow (current US$) in Belgium and Aid flow (current US$) in Denmark?
Offer a terse response. -1.38e+08. In the year 2013, what is the difference between the Aid flow (current US$) in Belgium and Aid flow (current US$) in Korea?
Your response must be concise. 3.09e+08. In the year 2013, what is the difference between the Aid flow (current US$) of Denmark and Aid flow (current US$) of Korea?
Give a very brief answer. 4.47e+08. What is the ratio of the Aid flow (current US$) in Austria in 2007 to that in 2008?
Ensure brevity in your answer.  3.03. What is the ratio of the Aid flow (current US$) in Belgium in 2007 to that in 2008?
Your response must be concise. 1.06. What is the ratio of the Aid flow (current US$) of Denmark in 2007 to that in 2008?
Keep it short and to the point. 1. What is the ratio of the Aid flow (current US$) of Korea in 2007 to that in 2008?
Keep it short and to the point. 0.66. What is the ratio of the Aid flow (current US$) of Austria in 2007 to that in 2009?
Your response must be concise. 3.06. What is the ratio of the Aid flow (current US$) in Belgium in 2007 to that in 2009?
Provide a short and direct response. 0.84. What is the ratio of the Aid flow (current US$) of Korea in 2007 to that in 2009?
Provide a succinct answer. 0.71. What is the ratio of the Aid flow (current US$) in Austria in 2007 to that in 2010?
Ensure brevity in your answer.  1.72. What is the ratio of the Aid flow (current US$) in Belgium in 2007 to that in 2010?
Provide a short and direct response. 0.54. What is the ratio of the Aid flow (current US$) of Denmark in 2007 to that in 2010?
Provide a succinct answer. 1.03. What is the ratio of the Aid flow (current US$) in Korea in 2007 to that in 2010?
Ensure brevity in your answer.  0.47. What is the ratio of the Aid flow (current US$) of Austria in 2007 to that in 2011?
Keep it short and to the point. 3.46. What is the ratio of the Aid flow (current US$) in Belgium in 2007 to that in 2011?
Your response must be concise. 0.82. What is the ratio of the Aid flow (current US$) in Denmark in 2007 to that in 2011?
Keep it short and to the point. 0.91. What is the ratio of the Aid flow (current US$) of Korea in 2007 to that in 2011?
Provide a short and direct response. 0.37. What is the ratio of the Aid flow (current US$) in Austria in 2007 to that in 2012?
Provide a short and direct response. 2.38. What is the ratio of the Aid flow (current US$) of Belgium in 2007 to that in 2012?
Your response must be concise. 0.84. What is the ratio of the Aid flow (current US$) of Denmark in 2007 to that in 2012?
Give a very brief answer. 1.11. What is the ratio of the Aid flow (current US$) in Korea in 2007 to that in 2012?
Give a very brief answer. 0.24. What is the ratio of the Aid flow (current US$) in Austria in 2007 to that in 2013?
Keep it short and to the point. 4.43. What is the ratio of the Aid flow (current US$) in Belgium in 2007 to that in 2013?
Your answer should be very brief. 1.13. What is the ratio of the Aid flow (current US$) of Denmark in 2007 to that in 2013?
Provide a short and direct response. 1.24. What is the ratio of the Aid flow (current US$) in Korea in 2007 to that in 2013?
Provide a succinct answer. 0.23. What is the ratio of the Aid flow (current US$) of Austria in 2008 to that in 2009?
Your response must be concise. 1.01. What is the ratio of the Aid flow (current US$) in Belgium in 2008 to that in 2009?
Provide a short and direct response. 0.79. What is the ratio of the Aid flow (current US$) in Korea in 2008 to that in 2009?
Your answer should be very brief. 1.08. What is the ratio of the Aid flow (current US$) of Austria in 2008 to that in 2010?
Your response must be concise. 0.57. What is the ratio of the Aid flow (current US$) of Belgium in 2008 to that in 2010?
Your answer should be compact. 0.51. What is the ratio of the Aid flow (current US$) in Denmark in 2008 to that in 2010?
Make the answer very short. 1.04. What is the ratio of the Aid flow (current US$) of Korea in 2008 to that in 2010?
Your answer should be compact. 0.7. What is the ratio of the Aid flow (current US$) of Austria in 2008 to that in 2011?
Offer a terse response. 1.14. What is the ratio of the Aid flow (current US$) of Belgium in 2008 to that in 2011?
Your answer should be very brief. 0.77. What is the ratio of the Aid flow (current US$) in Denmark in 2008 to that in 2011?
Give a very brief answer. 0.91. What is the ratio of the Aid flow (current US$) in Korea in 2008 to that in 2011?
Provide a short and direct response. 0.55. What is the ratio of the Aid flow (current US$) in Austria in 2008 to that in 2012?
Your answer should be compact. 0.79. What is the ratio of the Aid flow (current US$) of Belgium in 2008 to that in 2012?
Provide a short and direct response. 0.79. What is the ratio of the Aid flow (current US$) in Denmark in 2008 to that in 2012?
Make the answer very short. 1.12. What is the ratio of the Aid flow (current US$) of Korea in 2008 to that in 2012?
Offer a terse response. 0.36. What is the ratio of the Aid flow (current US$) in Austria in 2008 to that in 2013?
Provide a succinct answer. 1.46. What is the ratio of the Aid flow (current US$) of Belgium in 2008 to that in 2013?
Make the answer very short. 1.07. What is the ratio of the Aid flow (current US$) of Denmark in 2008 to that in 2013?
Provide a succinct answer. 1.24. What is the ratio of the Aid flow (current US$) of Korea in 2008 to that in 2013?
Keep it short and to the point. 0.35. What is the ratio of the Aid flow (current US$) of Austria in 2009 to that in 2010?
Offer a very short reply. 0.56. What is the ratio of the Aid flow (current US$) of Belgium in 2009 to that in 2010?
Your answer should be very brief. 0.64. What is the ratio of the Aid flow (current US$) in Denmark in 2009 to that in 2010?
Ensure brevity in your answer.  1.04. What is the ratio of the Aid flow (current US$) of Korea in 2009 to that in 2010?
Keep it short and to the point. 0.65. What is the ratio of the Aid flow (current US$) in Austria in 2009 to that in 2011?
Make the answer very short. 1.13. What is the ratio of the Aid flow (current US$) in Belgium in 2009 to that in 2011?
Provide a short and direct response. 0.97. What is the ratio of the Aid flow (current US$) in Denmark in 2009 to that in 2011?
Offer a very short reply. 0.91. What is the ratio of the Aid flow (current US$) in Korea in 2009 to that in 2011?
Your answer should be very brief. 0.52. What is the ratio of the Aid flow (current US$) in Austria in 2009 to that in 2012?
Your answer should be compact. 0.78. What is the ratio of the Aid flow (current US$) in Belgium in 2009 to that in 2012?
Your answer should be very brief. 1.01. What is the ratio of the Aid flow (current US$) in Denmark in 2009 to that in 2012?
Your answer should be compact. 1.12. What is the ratio of the Aid flow (current US$) of Korea in 2009 to that in 2012?
Offer a terse response. 0.34. What is the ratio of the Aid flow (current US$) of Austria in 2009 to that in 2013?
Provide a succinct answer. 1.45. What is the ratio of the Aid flow (current US$) in Belgium in 2009 to that in 2013?
Give a very brief answer. 1.35. What is the ratio of the Aid flow (current US$) in Denmark in 2009 to that in 2013?
Your answer should be very brief. 1.24. What is the ratio of the Aid flow (current US$) of Korea in 2009 to that in 2013?
Provide a succinct answer. 0.32. What is the ratio of the Aid flow (current US$) in Austria in 2010 to that in 2011?
Your answer should be very brief. 2.01. What is the ratio of the Aid flow (current US$) of Belgium in 2010 to that in 2011?
Offer a very short reply. 1.51. What is the ratio of the Aid flow (current US$) of Denmark in 2010 to that in 2011?
Offer a terse response. 0.88. What is the ratio of the Aid flow (current US$) of Korea in 2010 to that in 2011?
Make the answer very short. 0.79. What is the ratio of the Aid flow (current US$) in Austria in 2010 to that in 2012?
Provide a succinct answer. 1.38. What is the ratio of the Aid flow (current US$) of Belgium in 2010 to that in 2012?
Offer a terse response. 1.56. What is the ratio of the Aid flow (current US$) in Denmark in 2010 to that in 2012?
Give a very brief answer. 1.08. What is the ratio of the Aid flow (current US$) of Korea in 2010 to that in 2012?
Your answer should be compact. 0.51. What is the ratio of the Aid flow (current US$) in Austria in 2010 to that in 2013?
Offer a very short reply. 2.57. What is the ratio of the Aid flow (current US$) of Belgium in 2010 to that in 2013?
Offer a very short reply. 2.1. What is the ratio of the Aid flow (current US$) in Denmark in 2010 to that in 2013?
Your answer should be very brief. 1.19. What is the ratio of the Aid flow (current US$) in Korea in 2010 to that in 2013?
Give a very brief answer. 0.49. What is the ratio of the Aid flow (current US$) in Austria in 2011 to that in 2012?
Your answer should be compact. 0.69. What is the ratio of the Aid flow (current US$) of Belgium in 2011 to that in 2012?
Keep it short and to the point. 1.04. What is the ratio of the Aid flow (current US$) in Denmark in 2011 to that in 2012?
Ensure brevity in your answer.  1.23. What is the ratio of the Aid flow (current US$) in Korea in 2011 to that in 2012?
Offer a very short reply. 0.65. What is the ratio of the Aid flow (current US$) in Austria in 2011 to that in 2013?
Your response must be concise. 1.28. What is the ratio of the Aid flow (current US$) of Belgium in 2011 to that in 2013?
Your answer should be compact. 1.39. What is the ratio of the Aid flow (current US$) in Denmark in 2011 to that in 2013?
Ensure brevity in your answer.  1.36. What is the ratio of the Aid flow (current US$) in Korea in 2011 to that in 2013?
Make the answer very short. 0.62. What is the ratio of the Aid flow (current US$) of Austria in 2012 to that in 2013?
Offer a terse response. 1.86. What is the ratio of the Aid flow (current US$) of Belgium in 2012 to that in 2013?
Give a very brief answer. 1.34. What is the ratio of the Aid flow (current US$) in Denmark in 2012 to that in 2013?
Keep it short and to the point. 1.11. What is the ratio of the Aid flow (current US$) of Korea in 2012 to that in 2013?
Offer a very short reply. 0.95. What is the difference between the highest and the second highest Aid flow (current US$) of Austria?
Your answer should be compact. 1.64e+08. What is the difference between the highest and the second highest Aid flow (current US$) in Belgium?
Ensure brevity in your answer.  4.00e+08. What is the difference between the highest and the second highest Aid flow (current US$) in Denmark?
Offer a very short reply. 8.52e+07. What is the difference between the highest and the second highest Aid flow (current US$) of Korea?
Your response must be concise. 1.19e+07. What is the difference between the highest and the lowest Aid flow (current US$) in Austria?
Your answer should be compact. 3.03e+08. What is the difference between the highest and the lowest Aid flow (current US$) of Belgium?
Make the answer very short. 6.19e+08. What is the difference between the highest and the lowest Aid flow (current US$) of Denmark?
Give a very brief answer. 2.53e+08. What is the difference between the highest and the lowest Aid flow (current US$) of Korea?
Your answer should be very brief. 1.96e+08. 